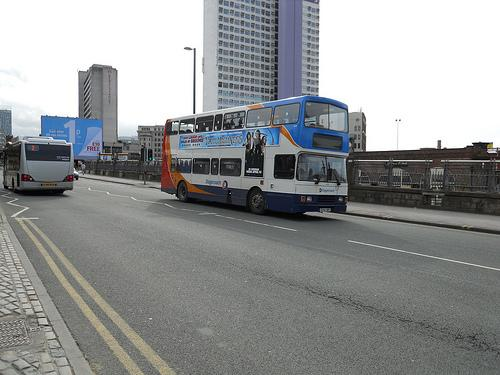What color is the billboard in the image, and where is it located? The billboard is blue and is located next to the street. Count and briefly describe the types of streetlights featured in the image. There is one street light, which is tall and cylindrical. What kind of street markings are present in the image? There are white dashed lines painted on the street. Using the information provided, what type of vehicle is the main focus of the image? The main focus of the image is a double decker bus. Determine the amount of wheels visible on the double decker bus in this image and describe their position. Two wheels are visible on the double decker bus, located near the bottom of the bus. Can you provide a brief description of the surroundings in the picture? The surroundings include a blue sky with scattered white clouds, a blue billboard, a street with white dashed lines, and a grey sidewalk. How would you describe the presence of clouds in the sky in the image? The sky has multiple white clouds scattered across the blue background. Identify any advertisement present in the image and describe its location. There's an advertisement on the double decker bus, located between the two sets of windows. Can you find any lights on the vehicles in this image? If so, describe their color and location. There is a red light on the bus, located near the back of the bus. Identify the types of buses and their colors in this image. There is a double decker bus that is blue and white, and a grey bus in the background. 